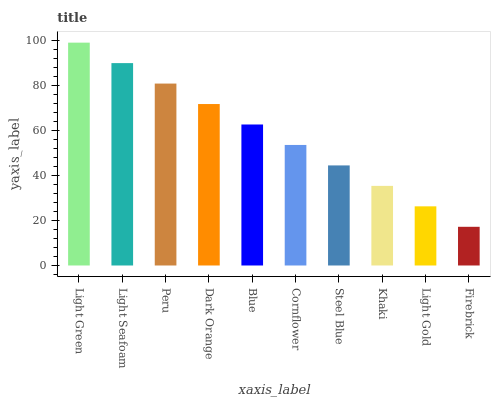Is Firebrick the minimum?
Answer yes or no. Yes. Is Light Green the maximum?
Answer yes or no. Yes. Is Light Seafoam the minimum?
Answer yes or no. No. Is Light Seafoam the maximum?
Answer yes or no. No. Is Light Green greater than Light Seafoam?
Answer yes or no. Yes. Is Light Seafoam less than Light Green?
Answer yes or no. Yes. Is Light Seafoam greater than Light Green?
Answer yes or no. No. Is Light Green less than Light Seafoam?
Answer yes or no. No. Is Blue the high median?
Answer yes or no. Yes. Is Cornflower the low median?
Answer yes or no. Yes. Is Peru the high median?
Answer yes or no. No. Is Blue the low median?
Answer yes or no. No. 